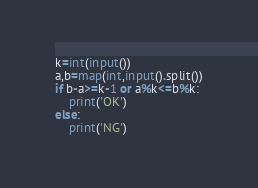<code> <loc_0><loc_0><loc_500><loc_500><_Python_>k=int(input())
a,b=map(int,input().split())
if b-a>=k-1 or a%k<=b%k:
    print('OK')
else:
    print('NG')</code> 